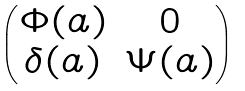Convert formula to latex. <formula><loc_0><loc_0><loc_500><loc_500>\begin{pmatrix} \Phi ( a ) & 0 \\ \delta ( a ) & \Psi ( a ) \end{pmatrix}</formula> 